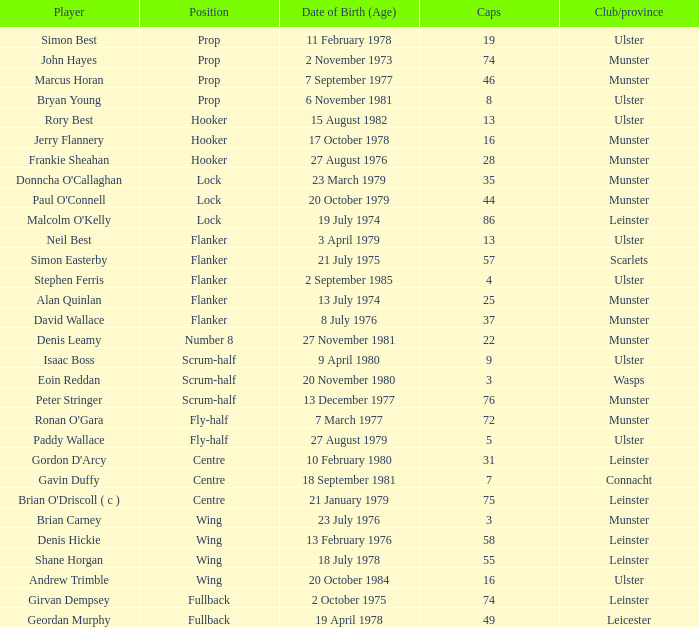Which player Munster from Munster is a fly-half? Ronan O'Gara. 